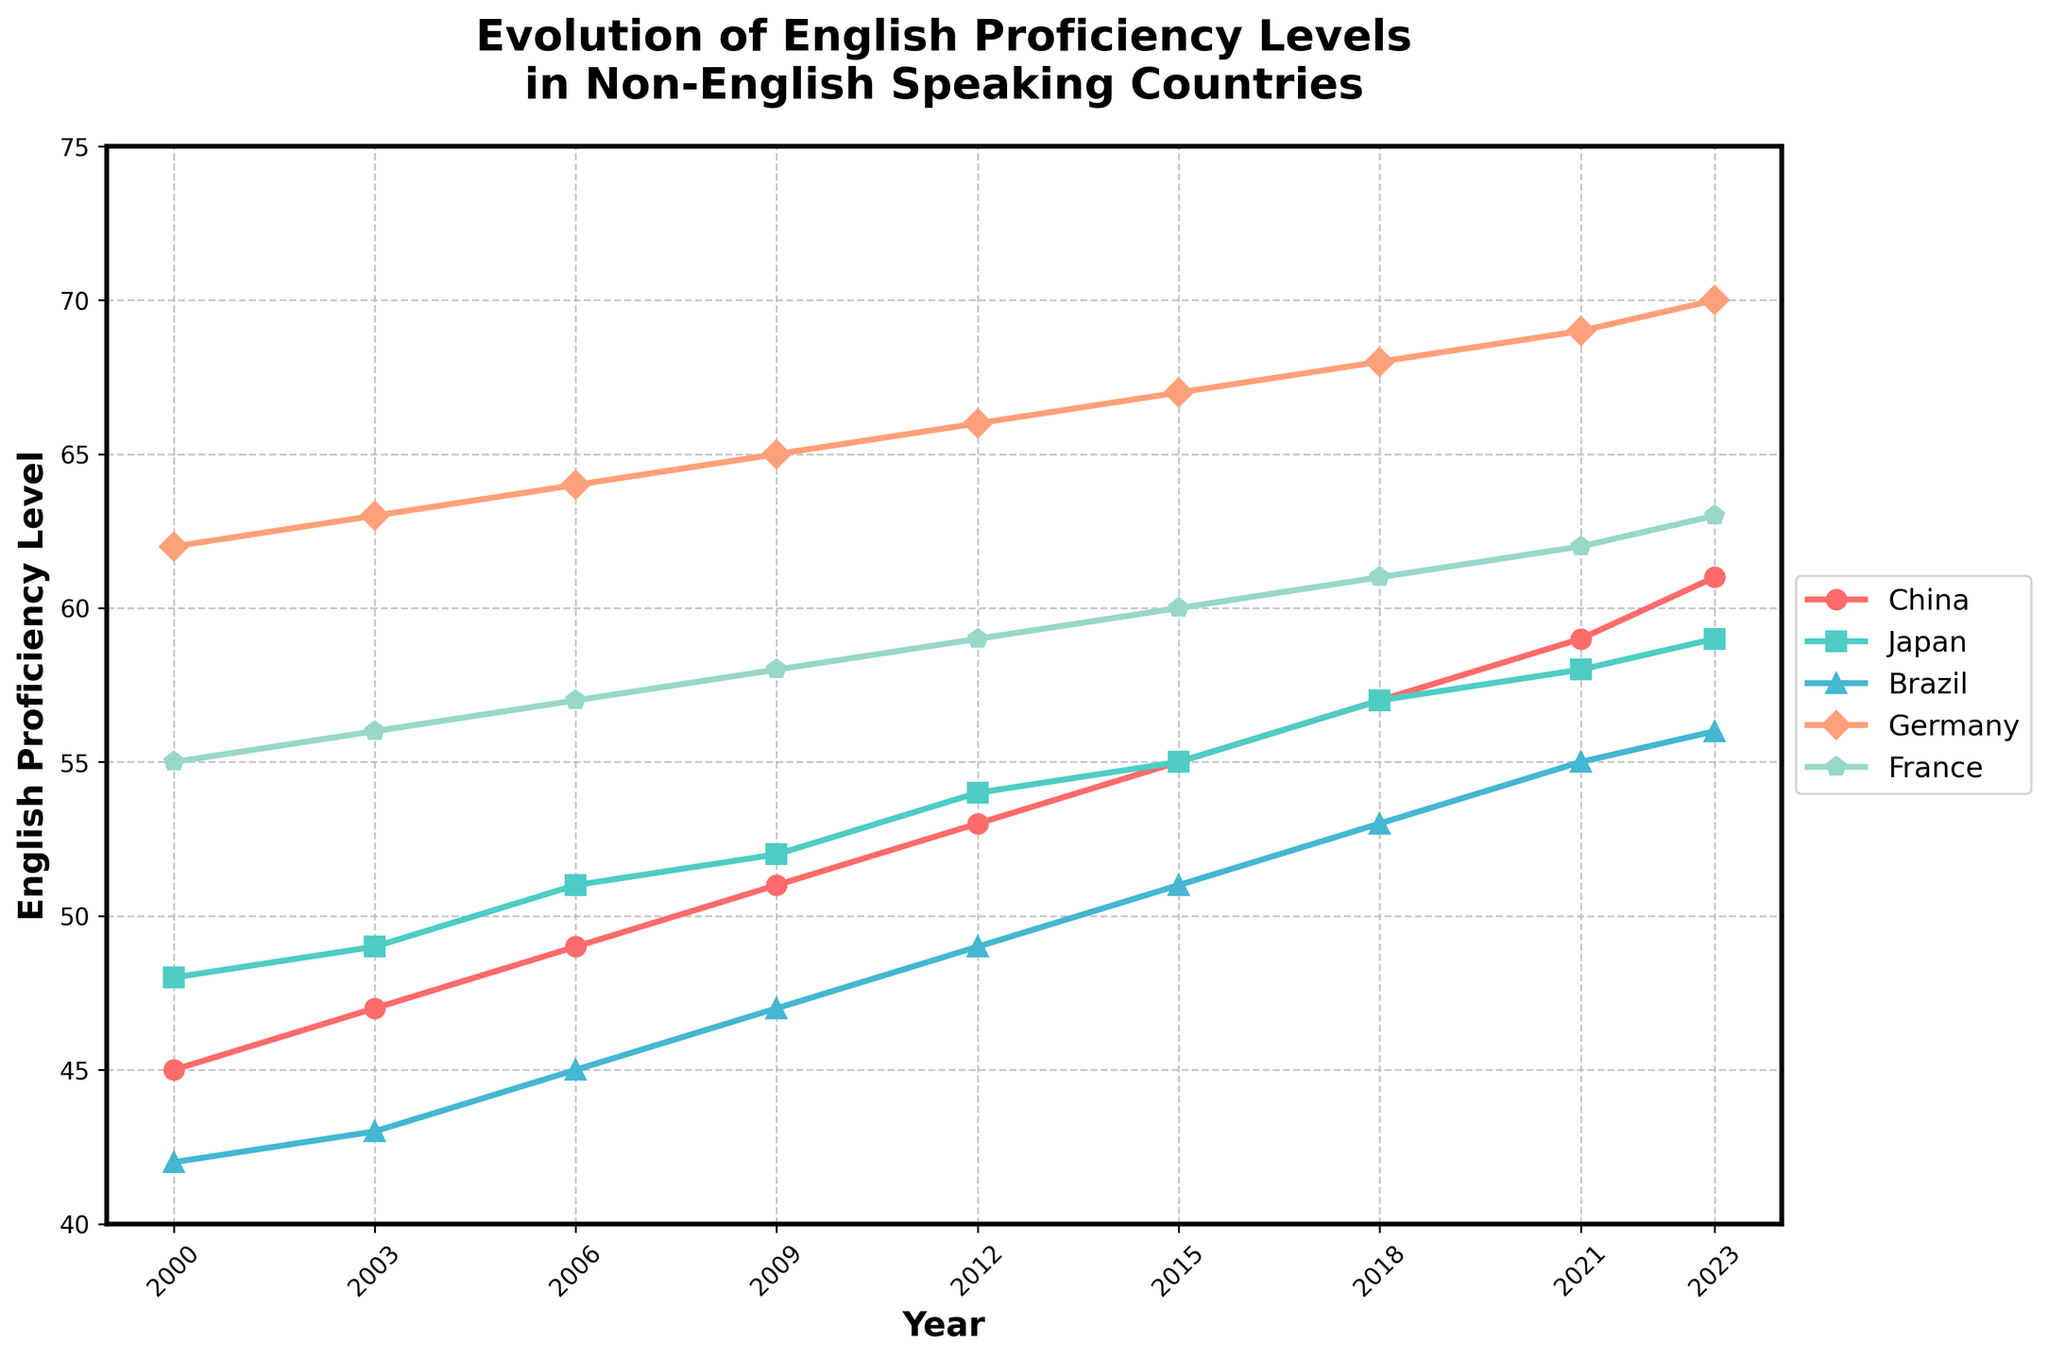What is the overall trend of English proficiency in China from 2000 to 2023? By looking at the line for China, you can see that it consistently rises from 45 in 2000 to 61 in 2023, indicating an upward trend in English proficiency.
Answer: Upward trend Which country had the highest English proficiency level in 2023? In 2023, the line for Germany is the highest among all countries at a proficiency level of 70.
Answer: Germany What is the average English proficiency level in France from 2000 to 2023? Add up the proficiency levels for France from 2000 to 2023 (55 + 56 + 57 + 58 + 59 + 60 + 61 + 62 + 63) which equals 531, then divide by the number of data points (9).
Answer: 59 How does the English proficiency in Germany in 2023 compare to that in 2000? In 2000, Germany had a proficiency level of 62, and in 2023, it is 70. The difference is 70 - 62 = 8.
Answer: 8 higher Between Japan and Brazil, which country showed the greater improvement in English proficiency from 2000 to 2023? For Japan, the increase is from 48 to 59 (11 points), and for Brazil, it is from 42 to 56 (14 points). Therefore, Brazil showed a greater improvement.
Answer: Brazil Which year did China surpass Brazil in English proficiency? By looking at the plot, China surpassed Brazil between 2006 and 2009, but it is clearly higher starting from 2009.
Answer: 2009 Which country had the least variation in English proficiency levels over the given period? To find the least variation, check the spread of data points for each country. Japan's values range from 48 to 59, marking the smallest difference (11).
Answer: Japan Calculate the average increase in English proficiency for Germany every three years between 2000 and 2021. Germany's levels: [62, 63, 64, 65, 66, 67, 68, 69]. Sum of differences: (63-62) + (64-63) + (65-64) + (66-65) + (67-66) + (68-67) + (69-68) = 7. Average: 7/7 = 1 point.
Answer: 1 point In which years did France have a higher English proficiency level than Japan? France's levels: [55, 56, 57, 58, 59, 60, 61, 62, 63]. Japan’s levels: [48, 49, 51, 52, 54, 55, 57, 58, 59]. Compare year by year: 2000-2023 except for 2006 to 2009, 2012, and 2018.
Answer: 2000, 2003, 2015, 2021, 2023 